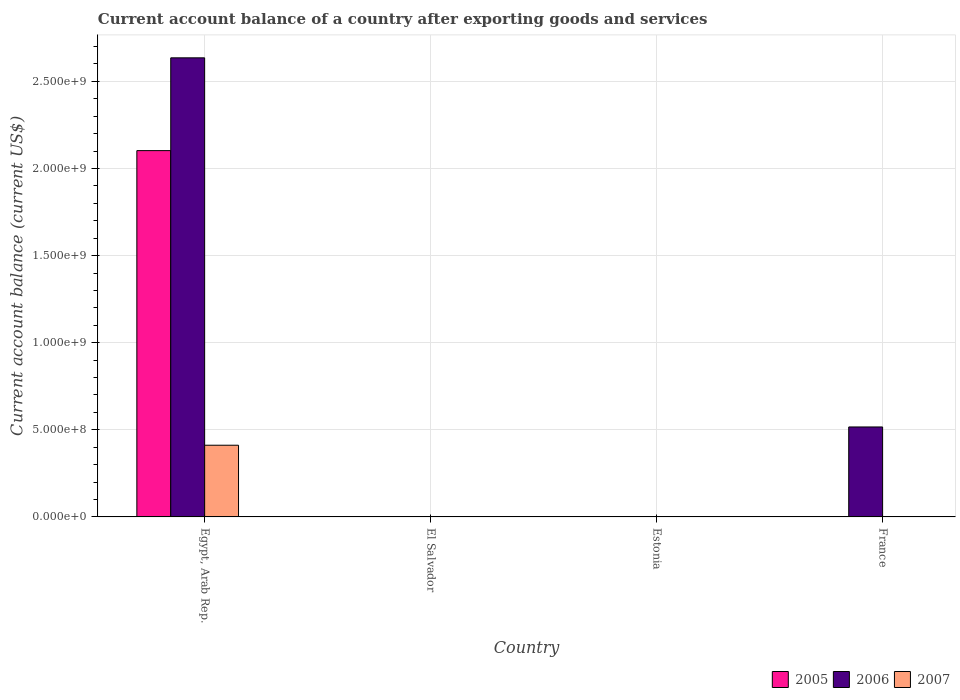How many different coloured bars are there?
Your answer should be very brief. 3. Are the number of bars per tick equal to the number of legend labels?
Your answer should be compact. No. Are the number of bars on each tick of the X-axis equal?
Provide a short and direct response. No. How many bars are there on the 1st tick from the right?
Your answer should be very brief. 1. What is the label of the 2nd group of bars from the left?
Keep it short and to the point. El Salvador. In how many cases, is the number of bars for a given country not equal to the number of legend labels?
Offer a terse response. 3. What is the account balance in 2005 in El Salvador?
Your answer should be compact. 0. Across all countries, what is the maximum account balance in 2007?
Your answer should be compact. 4.12e+08. In which country was the account balance in 2005 maximum?
Ensure brevity in your answer.  Egypt, Arab Rep. What is the total account balance in 2007 in the graph?
Provide a succinct answer. 4.12e+08. What is the difference between the account balance in 2005 in Estonia and the account balance in 2007 in Egypt, Arab Rep.?
Provide a short and direct response. -4.12e+08. What is the average account balance in 2006 per country?
Your response must be concise. 7.88e+08. What is the difference between the account balance of/in 2006 and account balance of/in 2005 in Egypt, Arab Rep.?
Your answer should be compact. 5.33e+08. What is the difference between the highest and the lowest account balance in 2007?
Your answer should be very brief. 4.12e+08. In how many countries, is the account balance in 2005 greater than the average account balance in 2005 taken over all countries?
Your answer should be very brief. 1. Is the sum of the account balance in 2006 in Egypt, Arab Rep. and France greater than the maximum account balance in 2005 across all countries?
Ensure brevity in your answer.  Yes. Is it the case that in every country, the sum of the account balance in 2007 and account balance in 2005 is greater than the account balance in 2006?
Keep it short and to the point. No. How many bars are there?
Make the answer very short. 4. What is the difference between two consecutive major ticks on the Y-axis?
Your response must be concise. 5.00e+08. Where does the legend appear in the graph?
Your answer should be compact. Bottom right. What is the title of the graph?
Provide a succinct answer. Current account balance of a country after exporting goods and services. What is the label or title of the Y-axis?
Ensure brevity in your answer.  Current account balance (current US$). What is the Current account balance (current US$) of 2005 in Egypt, Arab Rep.?
Make the answer very short. 2.10e+09. What is the Current account balance (current US$) in 2006 in Egypt, Arab Rep.?
Your answer should be very brief. 2.64e+09. What is the Current account balance (current US$) in 2007 in Egypt, Arab Rep.?
Provide a short and direct response. 4.12e+08. What is the Current account balance (current US$) in 2005 in El Salvador?
Provide a succinct answer. 0. What is the Current account balance (current US$) of 2005 in Estonia?
Keep it short and to the point. 0. What is the Current account balance (current US$) of 2006 in Estonia?
Make the answer very short. 0. What is the Current account balance (current US$) in 2007 in Estonia?
Give a very brief answer. 0. What is the Current account balance (current US$) in 2006 in France?
Your answer should be very brief. 5.16e+08. What is the Current account balance (current US$) of 2007 in France?
Make the answer very short. 0. Across all countries, what is the maximum Current account balance (current US$) of 2005?
Your answer should be very brief. 2.10e+09. Across all countries, what is the maximum Current account balance (current US$) of 2006?
Your response must be concise. 2.64e+09. Across all countries, what is the maximum Current account balance (current US$) in 2007?
Provide a short and direct response. 4.12e+08. Across all countries, what is the minimum Current account balance (current US$) in 2006?
Provide a short and direct response. 0. What is the total Current account balance (current US$) of 2005 in the graph?
Your answer should be compact. 2.10e+09. What is the total Current account balance (current US$) in 2006 in the graph?
Your response must be concise. 3.15e+09. What is the total Current account balance (current US$) of 2007 in the graph?
Provide a short and direct response. 4.12e+08. What is the difference between the Current account balance (current US$) in 2006 in Egypt, Arab Rep. and that in France?
Your answer should be very brief. 2.12e+09. What is the difference between the Current account balance (current US$) in 2005 in Egypt, Arab Rep. and the Current account balance (current US$) in 2006 in France?
Offer a terse response. 1.59e+09. What is the average Current account balance (current US$) of 2005 per country?
Your answer should be compact. 5.26e+08. What is the average Current account balance (current US$) in 2006 per country?
Provide a short and direct response. 7.88e+08. What is the average Current account balance (current US$) of 2007 per country?
Keep it short and to the point. 1.03e+08. What is the difference between the Current account balance (current US$) of 2005 and Current account balance (current US$) of 2006 in Egypt, Arab Rep.?
Keep it short and to the point. -5.33e+08. What is the difference between the Current account balance (current US$) in 2005 and Current account balance (current US$) in 2007 in Egypt, Arab Rep.?
Offer a terse response. 1.69e+09. What is the difference between the Current account balance (current US$) of 2006 and Current account balance (current US$) of 2007 in Egypt, Arab Rep.?
Your response must be concise. 2.22e+09. What is the ratio of the Current account balance (current US$) in 2006 in Egypt, Arab Rep. to that in France?
Make the answer very short. 5.1. What is the difference between the highest and the lowest Current account balance (current US$) of 2005?
Offer a terse response. 2.10e+09. What is the difference between the highest and the lowest Current account balance (current US$) of 2006?
Provide a succinct answer. 2.64e+09. What is the difference between the highest and the lowest Current account balance (current US$) of 2007?
Offer a terse response. 4.12e+08. 